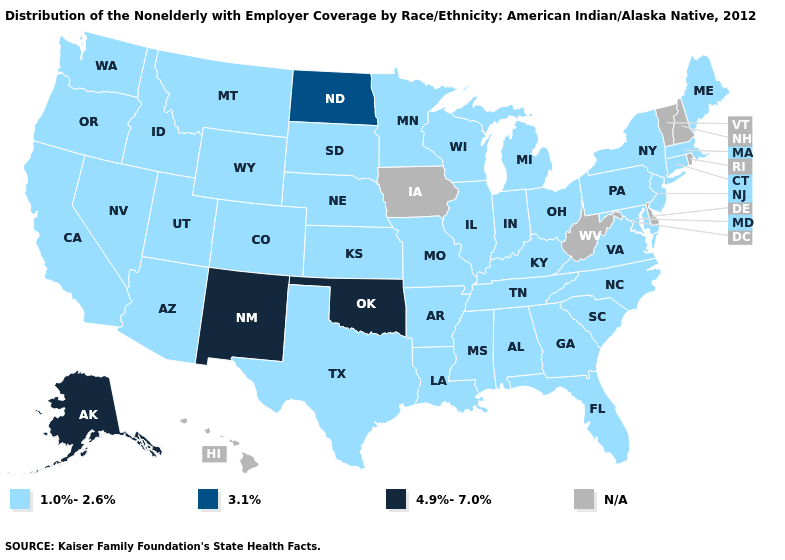What is the value of Kansas?
Keep it brief. 1.0%-2.6%. Name the states that have a value in the range 3.1%?
Concise answer only. North Dakota. Among the states that border Ohio , which have the highest value?
Short answer required. Indiana, Kentucky, Michigan, Pennsylvania. What is the highest value in the USA?
Keep it brief. 4.9%-7.0%. Does the map have missing data?
Quick response, please. Yes. Among the states that border Colorado , which have the highest value?
Concise answer only. New Mexico, Oklahoma. What is the highest value in the West ?
Give a very brief answer. 4.9%-7.0%. Does the map have missing data?
Be succinct. Yes. What is the value of South Carolina?
Keep it brief. 1.0%-2.6%. What is the highest value in states that border Maryland?
Answer briefly. 1.0%-2.6%. Which states have the lowest value in the USA?
Short answer required. Alabama, Arizona, Arkansas, California, Colorado, Connecticut, Florida, Georgia, Idaho, Illinois, Indiana, Kansas, Kentucky, Louisiana, Maine, Maryland, Massachusetts, Michigan, Minnesota, Mississippi, Missouri, Montana, Nebraska, Nevada, New Jersey, New York, North Carolina, Ohio, Oregon, Pennsylvania, South Carolina, South Dakota, Tennessee, Texas, Utah, Virginia, Washington, Wisconsin, Wyoming. Does the map have missing data?
Write a very short answer. Yes. Does Oklahoma have the lowest value in the South?
Keep it brief. No. Does New Mexico have the lowest value in the USA?
Write a very short answer. No. 